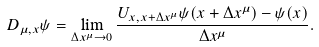<formula> <loc_0><loc_0><loc_500><loc_500>D _ { \mu , x } \psi = \lim _ { \Delta x ^ { \mu } \rightarrow 0 } \frac { U _ { x , x + \Delta x ^ { \mu } } \psi ( x + \Delta x ^ { \mu } ) - \psi ( x ) } { \Delta x ^ { \mu } } .</formula> 